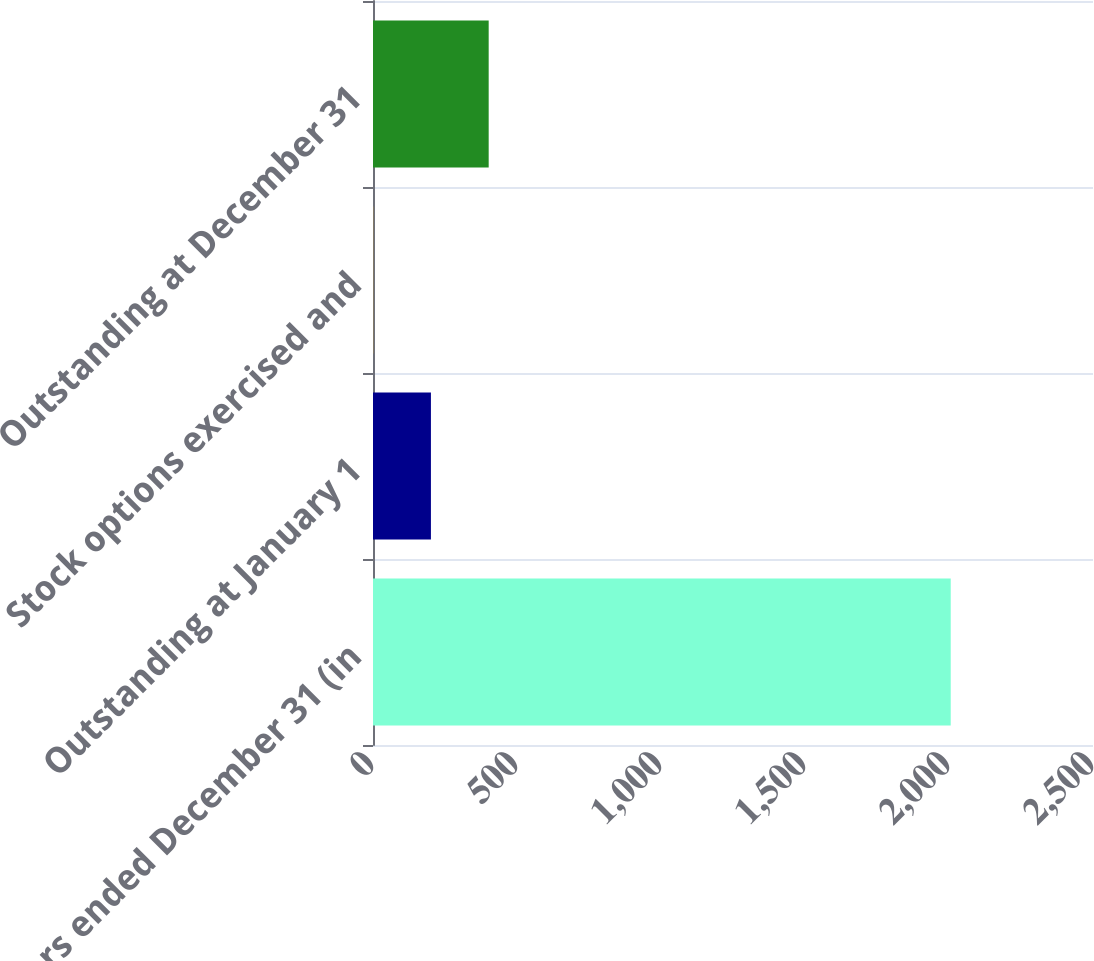Convert chart to OTSL. <chart><loc_0><loc_0><loc_500><loc_500><bar_chart><fcel>Years ended December 31 (in<fcel>Outstanding at January 1<fcel>Stock options exercised and<fcel>Outstanding at December 31<nl><fcel>2006<fcel>201.14<fcel>0.6<fcel>401.68<nl></chart> 